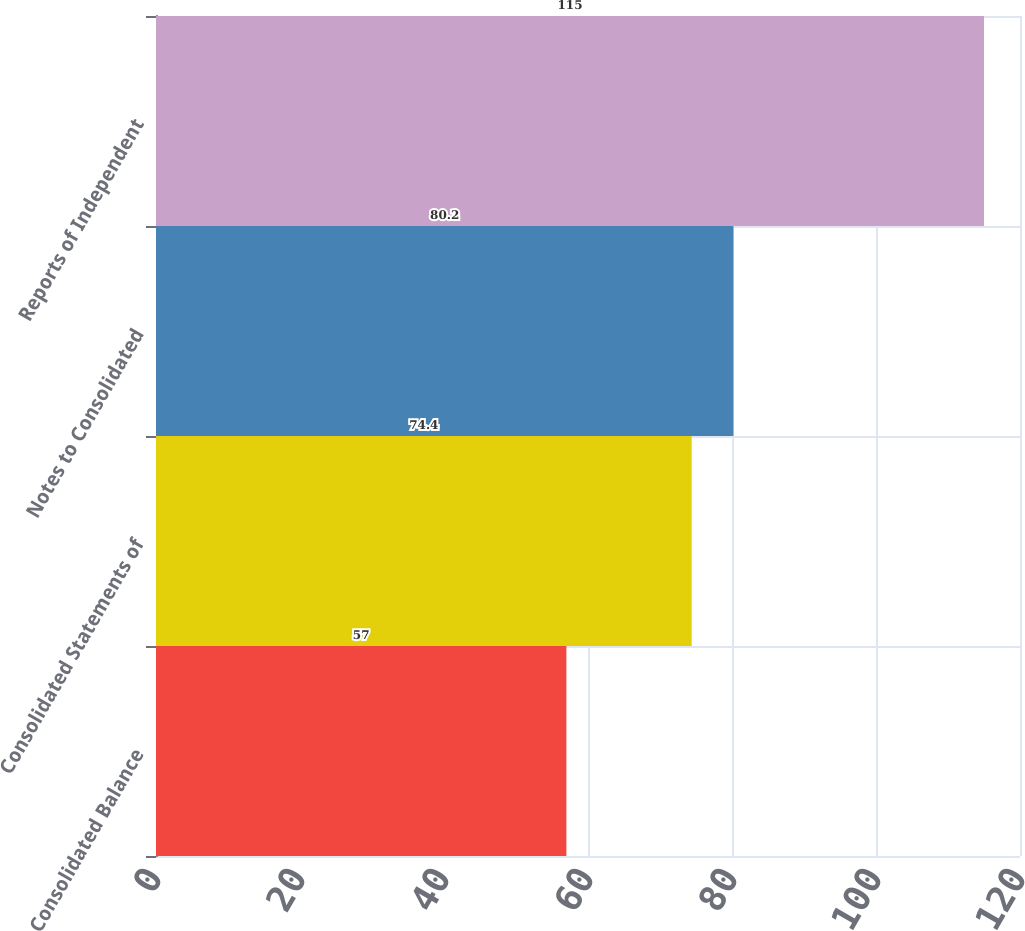<chart> <loc_0><loc_0><loc_500><loc_500><bar_chart><fcel>Consolidated Balance<fcel>Consolidated Statements of<fcel>Notes to Consolidated<fcel>Reports of Independent<nl><fcel>57<fcel>74.4<fcel>80.2<fcel>115<nl></chart> 